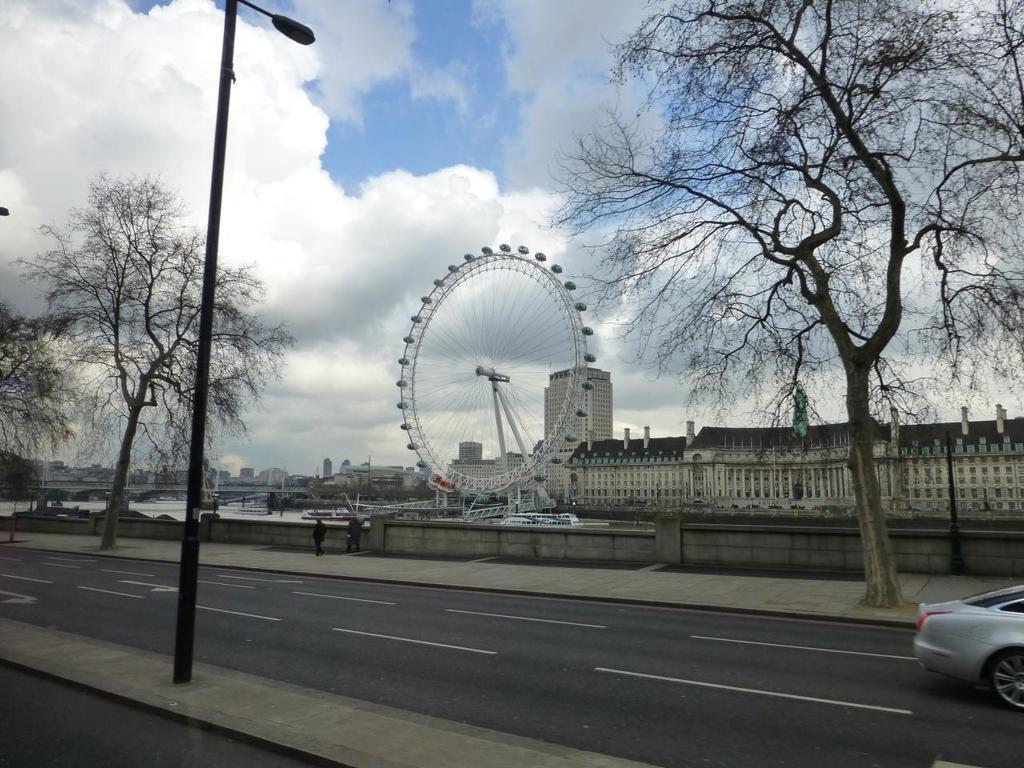In one or two sentences, can you explain what this image depicts? On the bottom right corner there is a car on the road. Here we can see two person standing near to the fencing. On the left there is a street light. In the background we can see trees, buildings, boat, water and bridge. On the top we can see sky and clouds. 